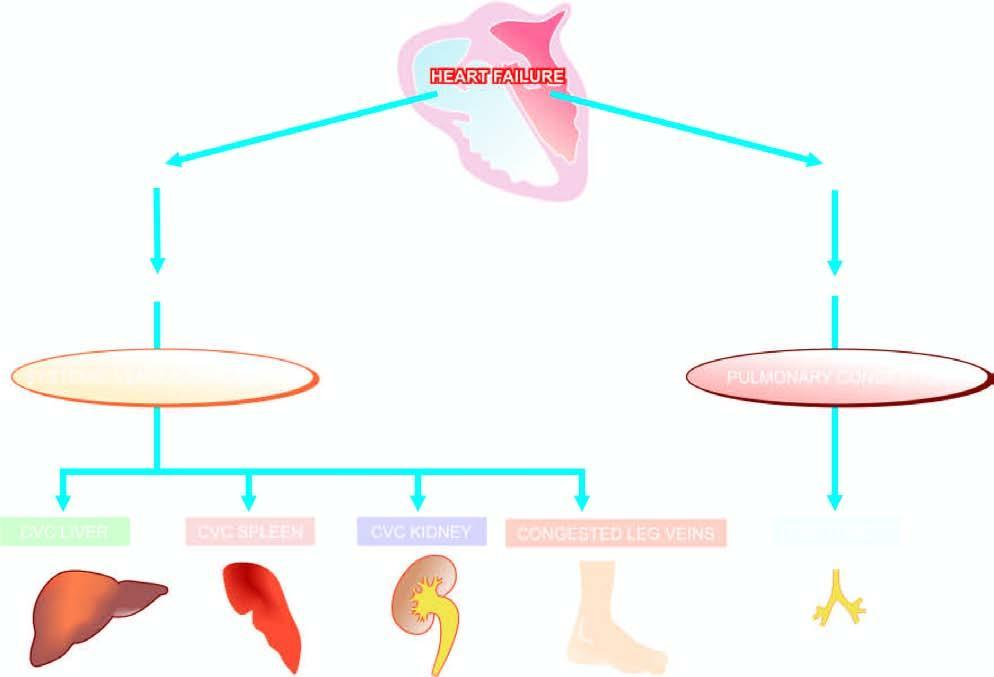s chematic representation of mechanisms involved in chronic venous congestion of different organs?
Answer the question using a single word or phrase. Yes 